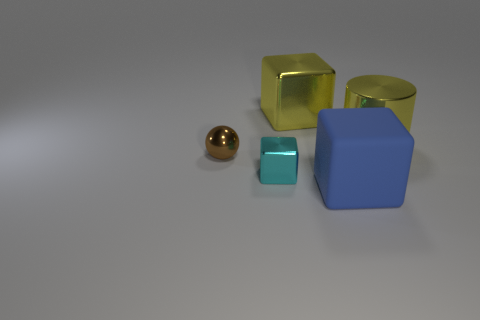What materials do the objects in the image seem to be made of? The objects in the image appear to be made of a glossy material, likely plastic, as they exhibit a shiny surface that reflects light. 